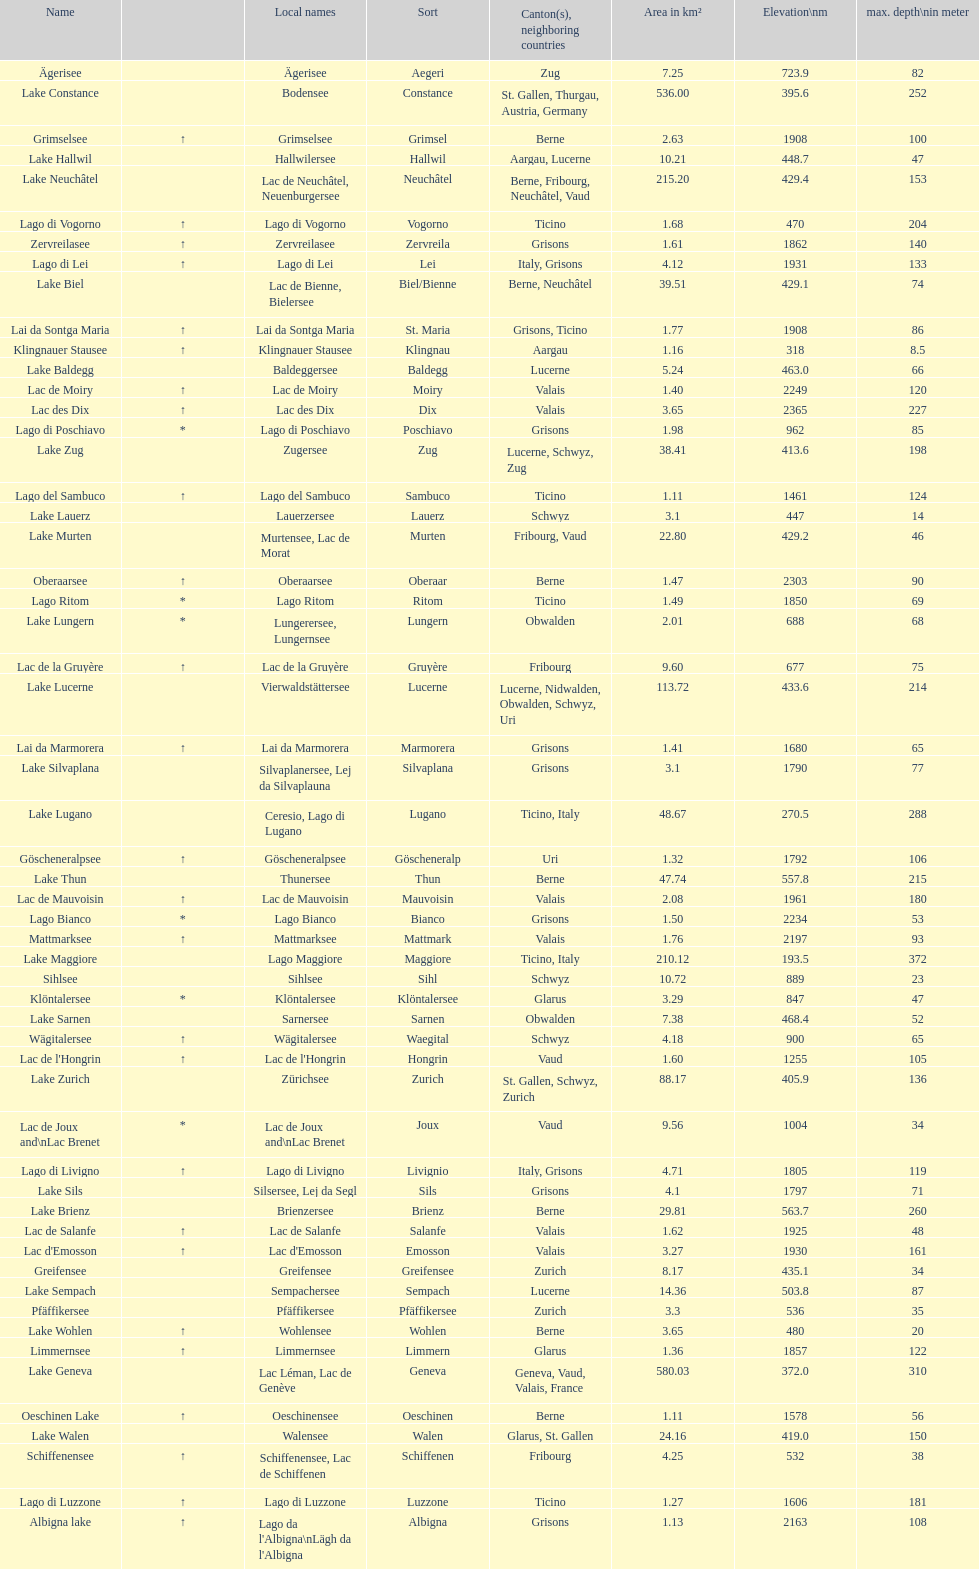Between albigna lake and oeschinen lake, which one has a smaller area in km²? Oeschinen Lake. 